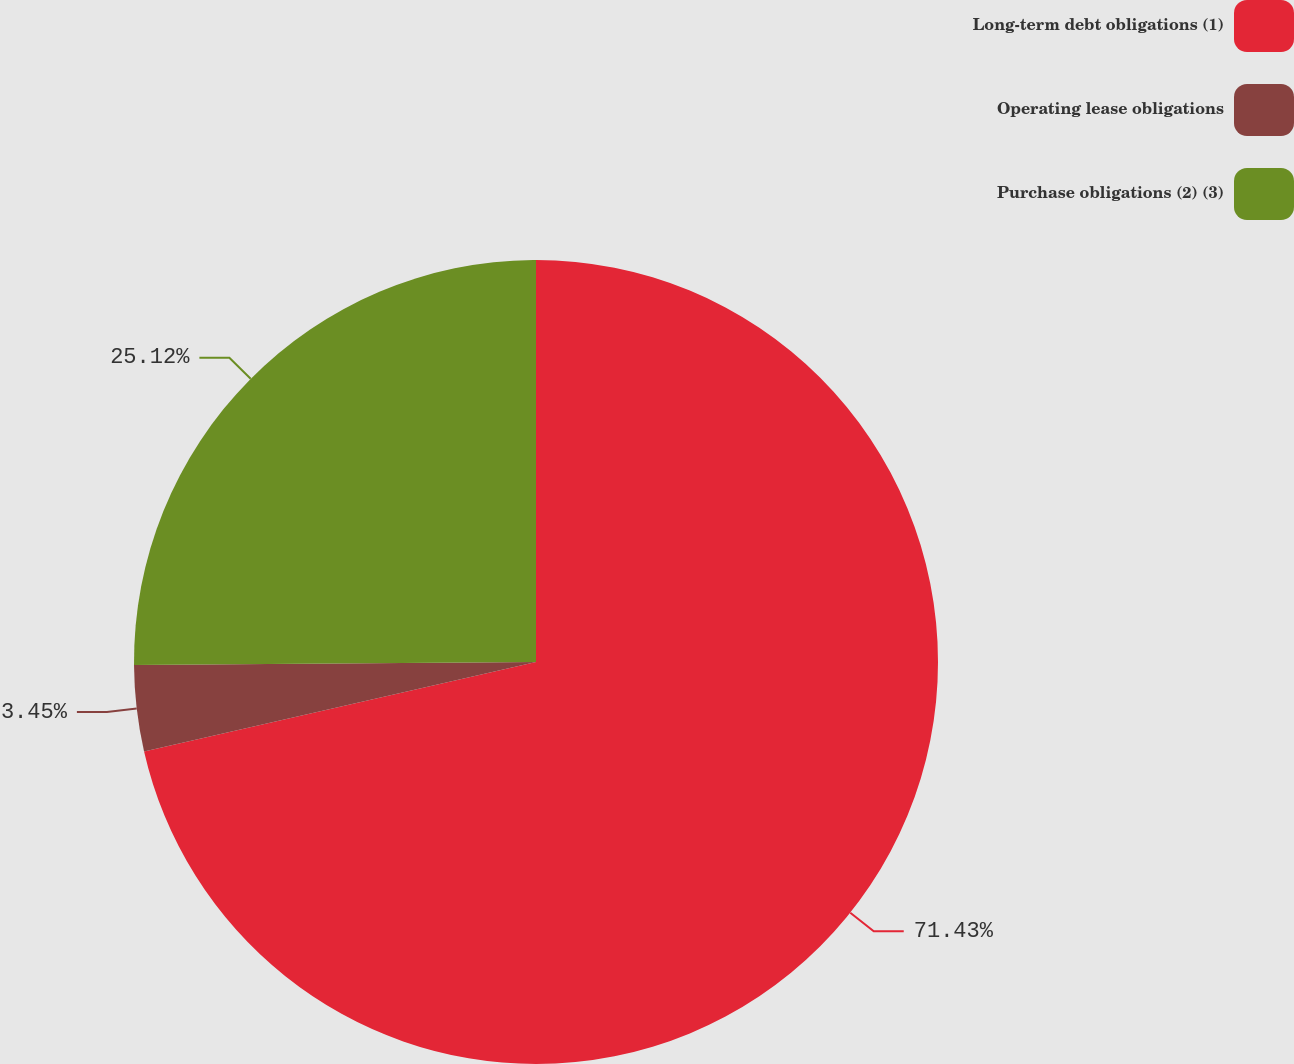Convert chart to OTSL. <chart><loc_0><loc_0><loc_500><loc_500><pie_chart><fcel>Long-term debt obligations (1)<fcel>Operating lease obligations<fcel>Purchase obligations (2) (3)<nl><fcel>71.43%<fcel>3.45%<fcel>25.12%<nl></chart> 